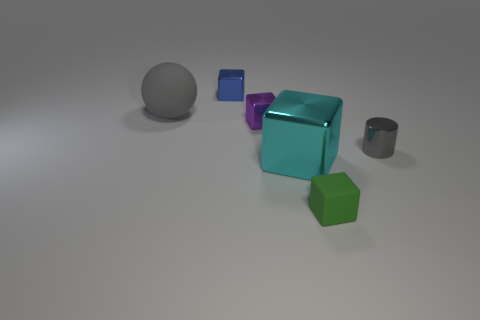What shape is the gray rubber object?
Ensure brevity in your answer.  Sphere. What material is the thing that is in front of the cyan metallic block?
Offer a terse response. Rubber. Are there any rubber spheres that have the same color as the small metal cylinder?
Your answer should be very brief. Yes. The green matte object that is the same size as the purple thing is what shape?
Ensure brevity in your answer.  Cube. There is a small metal thing behind the large gray rubber thing; what is its color?
Your response must be concise. Blue. There is a small thing to the left of the purple block; are there any big cyan shiny objects in front of it?
Offer a terse response. Yes. How many objects are either small blocks left of the tiny purple shiny thing or small gray metallic objects?
Offer a terse response. 2. There is a small block in front of the gray thing on the right side of the purple shiny block; what is it made of?
Your response must be concise. Rubber. Are there the same number of rubber balls in front of the big gray matte object and small blocks that are behind the small purple thing?
Your answer should be very brief. No. What number of objects are either shiny objects that are to the right of the green thing or shiny things that are behind the purple shiny object?
Ensure brevity in your answer.  2. 